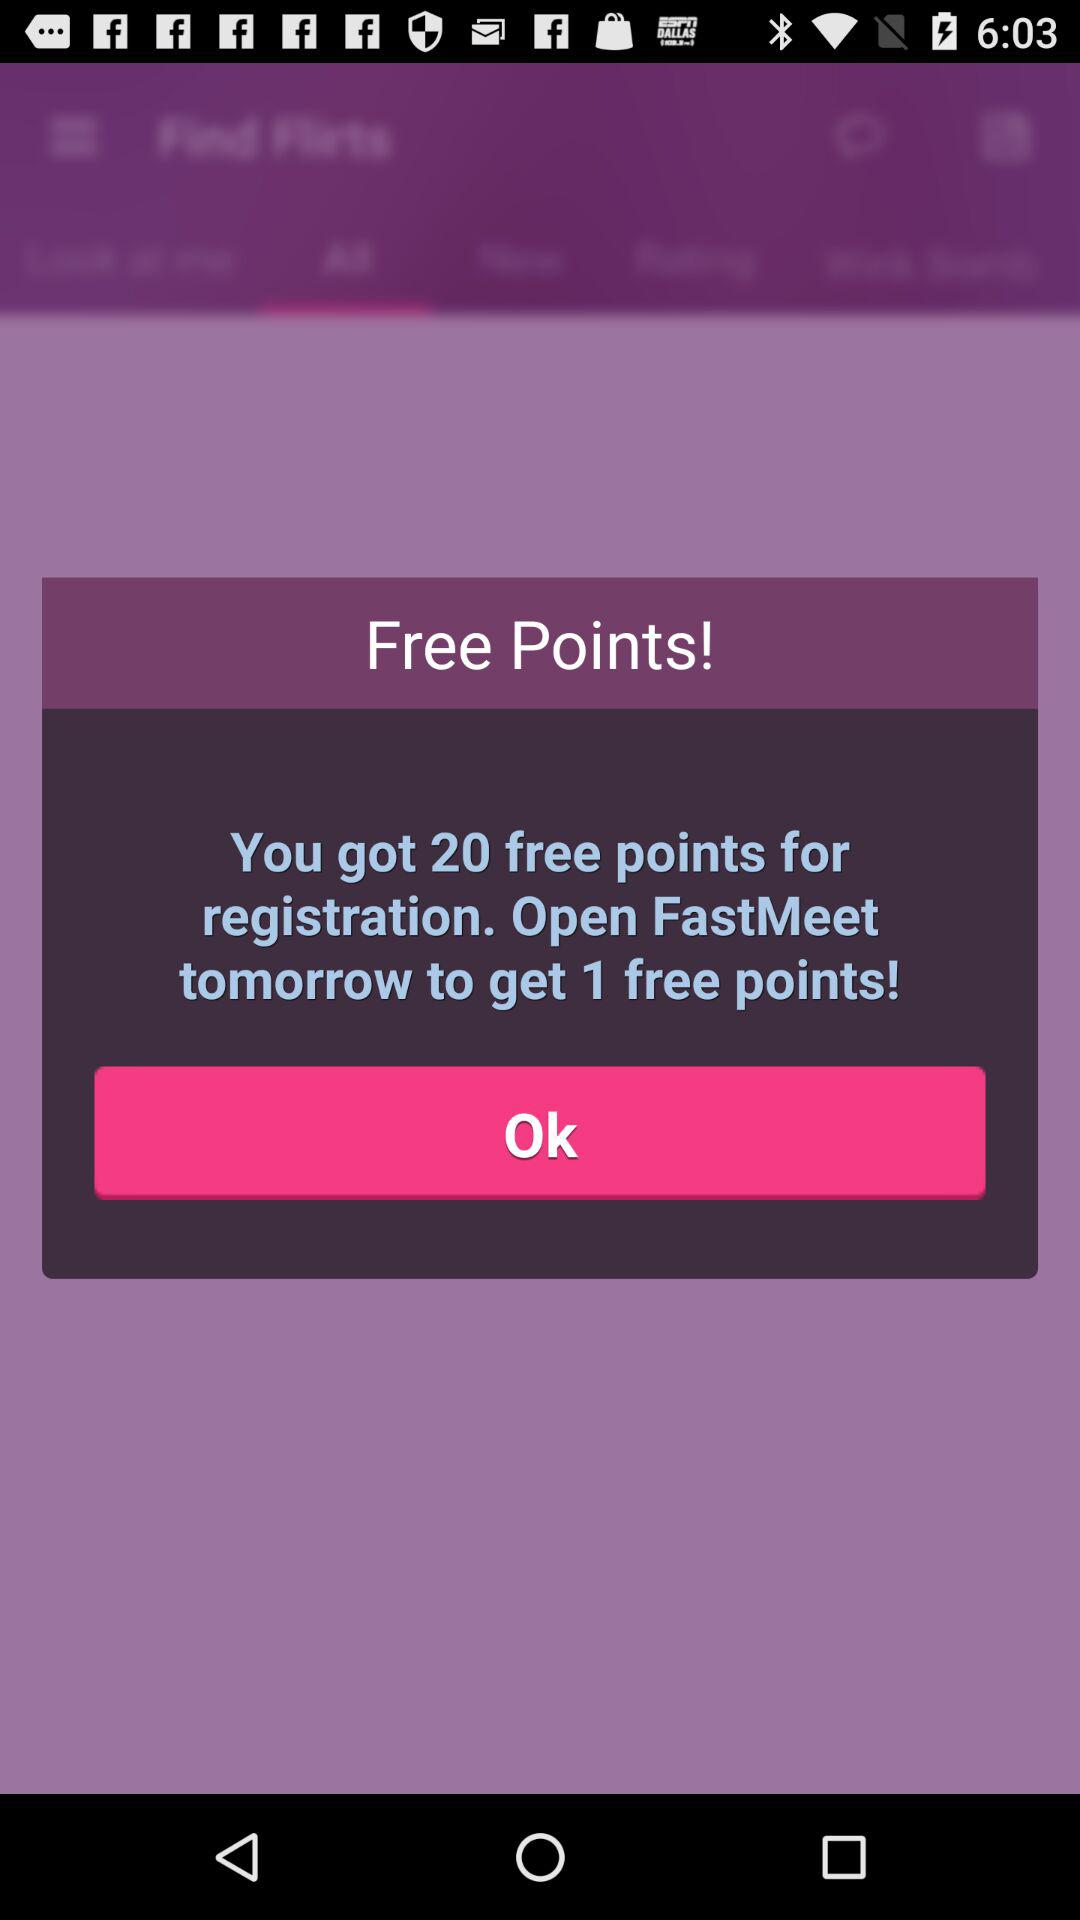How many free points did the user get for the registration? The user got 20 free points for the registration. 